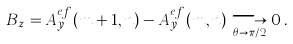<formula> <loc_0><loc_0><loc_500><loc_500>B _ { z } = A ^ { e f } _ { y } ( m + 1 , n ) - A ^ { e f } _ { y } ( m , n ) \underset { \theta \rightarrow \pi / 2 } \longrightarrow 0 \, .</formula> 